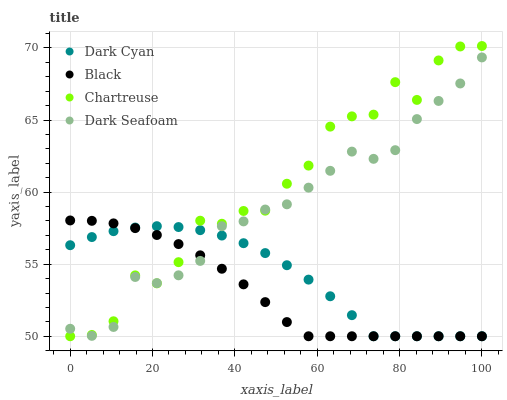Does Black have the minimum area under the curve?
Answer yes or no. Yes. Does Chartreuse have the maximum area under the curve?
Answer yes or no. Yes. Does Chartreuse have the minimum area under the curve?
Answer yes or no. No. Does Black have the maximum area under the curve?
Answer yes or no. No. Is Black the smoothest?
Answer yes or no. Yes. Is Chartreuse the roughest?
Answer yes or no. Yes. Is Chartreuse the smoothest?
Answer yes or no. No. Is Black the roughest?
Answer yes or no. No. Does Dark Cyan have the lowest value?
Answer yes or no. Yes. Does Dark Seafoam have the lowest value?
Answer yes or no. No. Does Chartreuse have the highest value?
Answer yes or no. Yes. Does Black have the highest value?
Answer yes or no. No. Does Chartreuse intersect Black?
Answer yes or no. Yes. Is Chartreuse less than Black?
Answer yes or no. No. Is Chartreuse greater than Black?
Answer yes or no. No. 